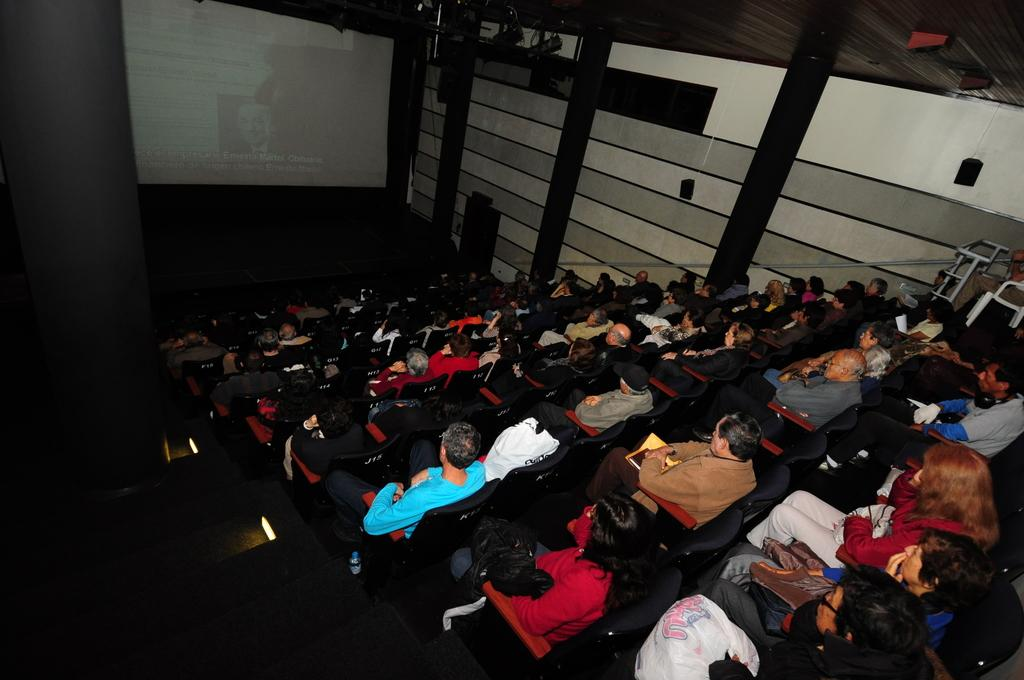What are the people in the image doing? The people in the image are sitting on chairs. What can be seen in the background of the image? There is a screen in the background of the image. What object is present in the image that is used for amplifying sound? There is a speaker in the image. What type of basket is being used to catch sneezes in the image? There is no basket or sneezes present in the image. 